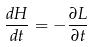<formula> <loc_0><loc_0><loc_500><loc_500>\frac { d H } { d t } = - \frac { \partial L } { \partial t }</formula> 